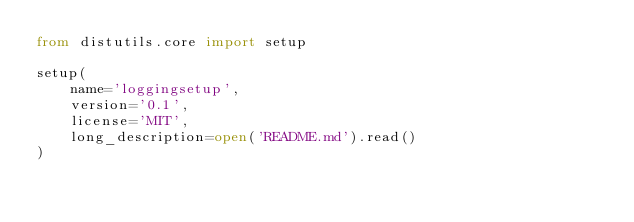<code> <loc_0><loc_0><loc_500><loc_500><_Python_>from distutils.core import setup

setup(
    name='loggingsetup',
    version='0.1',
    license='MIT',
    long_description=open('README.md').read()
)
</code> 